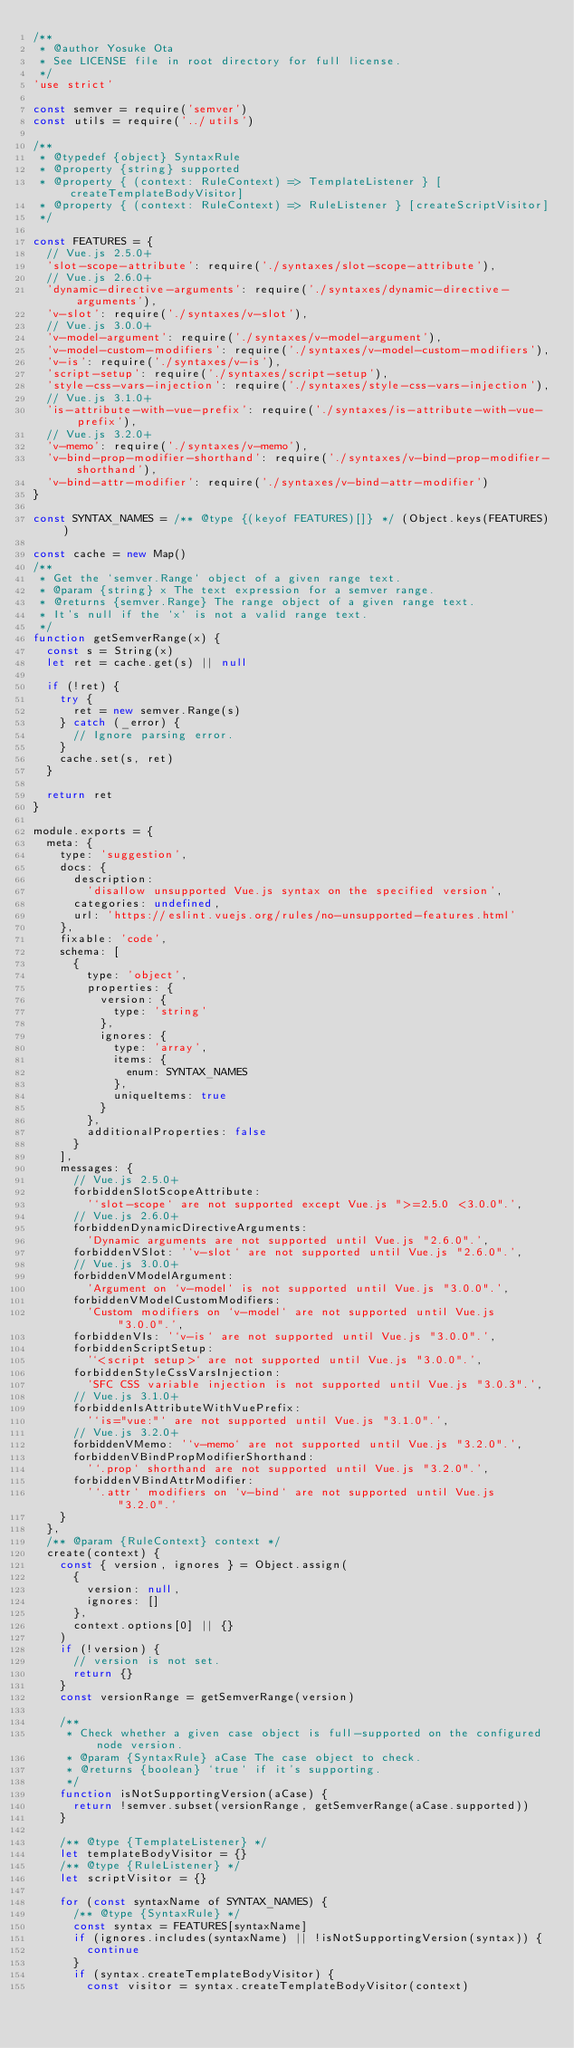<code> <loc_0><loc_0><loc_500><loc_500><_JavaScript_>/**
 * @author Yosuke Ota
 * See LICENSE file in root directory for full license.
 */
'use strict'

const semver = require('semver')
const utils = require('../utils')

/**
 * @typedef {object} SyntaxRule
 * @property {string} supported
 * @property { (context: RuleContext) => TemplateListener } [createTemplateBodyVisitor]
 * @property { (context: RuleContext) => RuleListener } [createScriptVisitor]
 */

const FEATURES = {
  // Vue.js 2.5.0+
  'slot-scope-attribute': require('./syntaxes/slot-scope-attribute'),
  // Vue.js 2.6.0+
  'dynamic-directive-arguments': require('./syntaxes/dynamic-directive-arguments'),
  'v-slot': require('./syntaxes/v-slot'),
  // Vue.js 3.0.0+
  'v-model-argument': require('./syntaxes/v-model-argument'),
  'v-model-custom-modifiers': require('./syntaxes/v-model-custom-modifiers'),
  'v-is': require('./syntaxes/v-is'),
  'script-setup': require('./syntaxes/script-setup'),
  'style-css-vars-injection': require('./syntaxes/style-css-vars-injection'),
  // Vue.js 3.1.0+
  'is-attribute-with-vue-prefix': require('./syntaxes/is-attribute-with-vue-prefix'),
  // Vue.js 3.2.0+
  'v-memo': require('./syntaxes/v-memo'),
  'v-bind-prop-modifier-shorthand': require('./syntaxes/v-bind-prop-modifier-shorthand'),
  'v-bind-attr-modifier': require('./syntaxes/v-bind-attr-modifier')
}

const SYNTAX_NAMES = /** @type {(keyof FEATURES)[]} */ (Object.keys(FEATURES))

const cache = new Map()
/**
 * Get the `semver.Range` object of a given range text.
 * @param {string} x The text expression for a semver range.
 * @returns {semver.Range} The range object of a given range text.
 * It's null if the `x` is not a valid range text.
 */
function getSemverRange(x) {
  const s = String(x)
  let ret = cache.get(s) || null

  if (!ret) {
    try {
      ret = new semver.Range(s)
    } catch (_error) {
      // Ignore parsing error.
    }
    cache.set(s, ret)
  }

  return ret
}

module.exports = {
  meta: {
    type: 'suggestion',
    docs: {
      description:
        'disallow unsupported Vue.js syntax on the specified version',
      categories: undefined,
      url: 'https://eslint.vuejs.org/rules/no-unsupported-features.html'
    },
    fixable: 'code',
    schema: [
      {
        type: 'object',
        properties: {
          version: {
            type: 'string'
          },
          ignores: {
            type: 'array',
            items: {
              enum: SYNTAX_NAMES
            },
            uniqueItems: true
          }
        },
        additionalProperties: false
      }
    ],
    messages: {
      // Vue.js 2.5.0+
      forbiddenSlotScopeAttribute:
        '`slot-scope` are not supported except Vue.js ">=2.5.0 <3.0.0".',
      // Vue.js 2.6.0+
      forbiddenDynamicDirectiveArguments:
        'Dynamic arguments are not supported until Vue.js "2.6.0".',
      forbiddenVSlot: '`v-slot` are not supported until Vue.js "2.6.0".',
      // Vue.js 3.0.0+
      forbiddenVModelArgument:
        'Argument on `v-model` is not supported until Vue.js "3.0.0".',
      forbiddenVModelCustomModifiers:
        'Custom modifiers on `v-model` are not supported until Vue.js "3.0.0".',
      forbiddenVIs: '`v-is` are not supported until Vue.js "3.0.0".',
      forbiddenScriptSetup:
        '`<script setup>` are not supported until Vue.js "3.0.0".',
      forbiddenStyleCssVarsInjection:
        'SFC CSS variable injection is not supported until Vue.js "3.0.3".',
      // Vue.js 3.1.0+
      forbiddenIsAttributeWithVuePrefix:
        '`is="vue:"` are not supported until Vue.js "3.1.0".',
      // Vue.js 3.2.0+
      forbiddenVMemo: '`v-memo` are not supported until Vue.js "3.2.0".',
      forbiddenVBindPropModifierShorthand:
        '`.prop` shorthand are not supported until Vue.js "3.2.0".',
      forbiddenVBindAttrModifier:
        '`.attr` modifiers on `v-bind` are not supported until Vue.js "3.2.0".'
    }
  },
  /** @param {RuleContext} context */
  create(context) {
    const { version, ignores } = Object.assign(
      {
        version: null,
        ignores: []
      },
      context.options[0] || {}
    )
    if (!version) {
      // version is not set.
      return {}
    }
    const versionRange = getSemverRange(version)

    /**
     * Check whether a given case object is full-supported on the configured node version.
     * @param {SyntaxRule} aCase The case object to check.
     * @returns {boolean} `true` if it's supporting.
     */
    function isNotSupportingVersion(aCase) {
      return !semver.subset(versionRange, getSemverRange(aCase.supported))
    }

    /** @type {TemplateListener} */
    let templateBodyVisitor = {}
    /** @type {RuleListener} */
    let scriptVisitor = {}

    for (const syntaxName of SYNTAX_NAMES) {
      /** @type {SyntaxRule} */
      const syntax = FEATURES[syntaxName]
      if (ignores.includes(syntaxName) || !isNotSupportingVersion(syntax)) {
        continue
      }
      if (syntax.createTemplateBodyVisitor) {
        const visitor = syntax.createTemplateBodyVisitor(context)</code> 